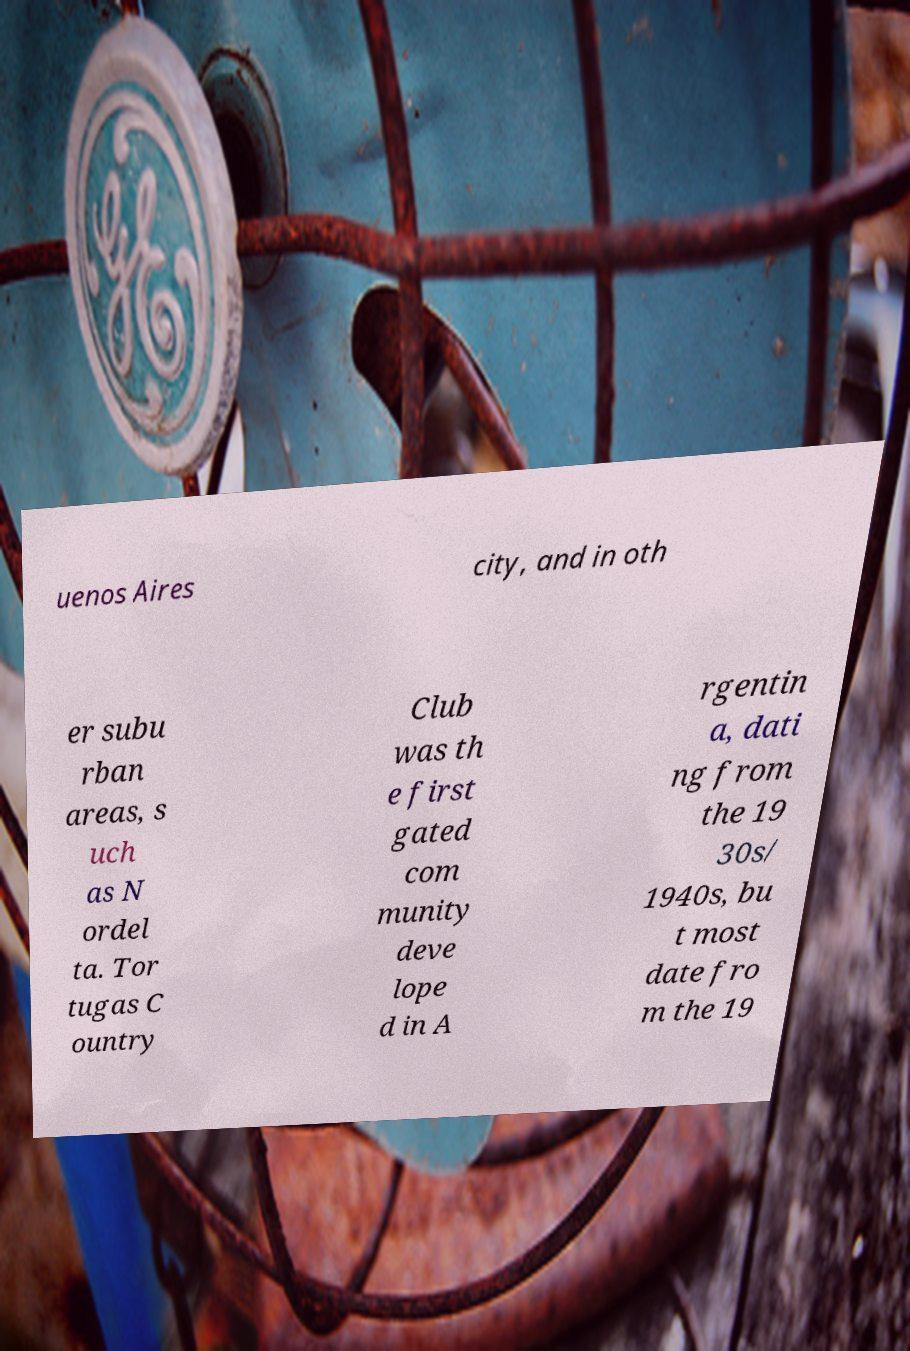For documentation purposes, I need the text within this image transcribed. Could you provide that? uenos Aires city, and in oth er subu rban areas, s uch as N ordel ta. Tor tugas C ountry Club was th e first gated com munity deve lope d in A rgentin a, dati ng from the 19 30s/ 1940s, bu t most date fro m the 19 